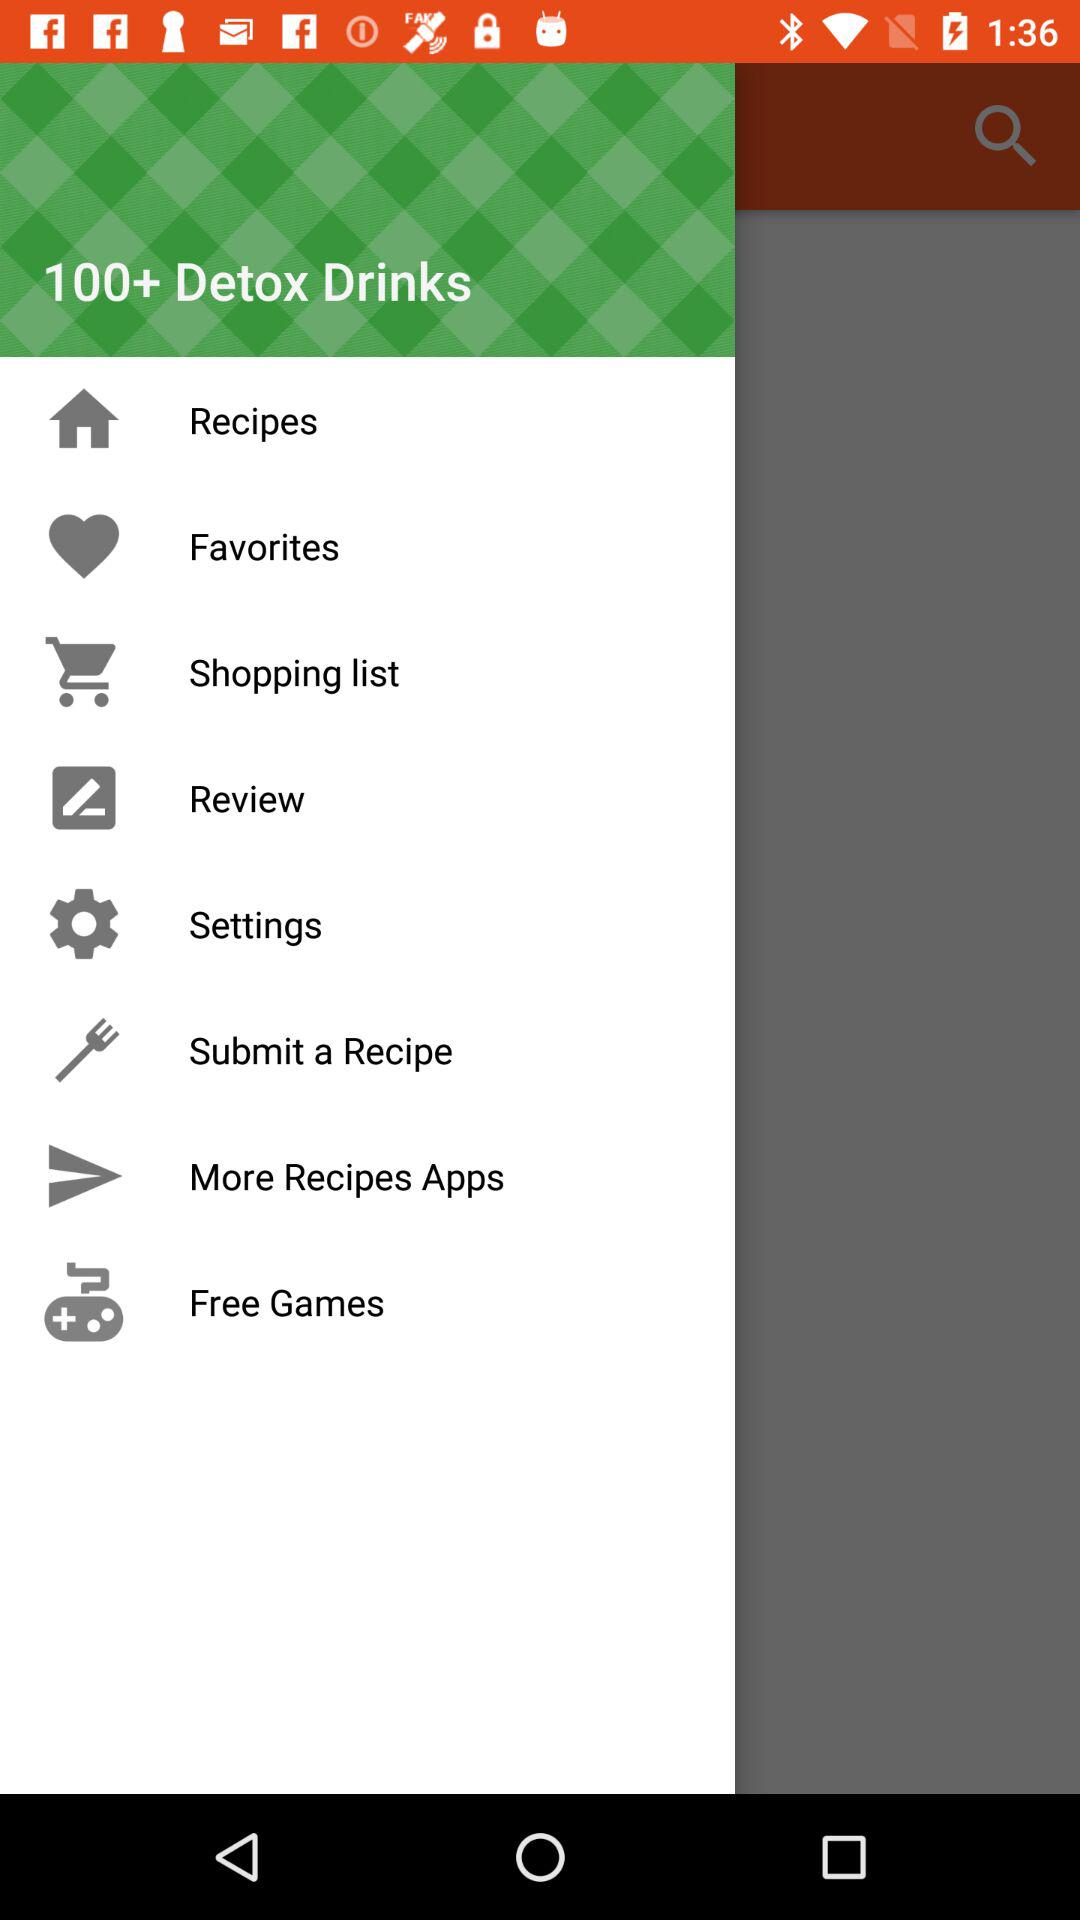What is the application name? The application name is "100+ Detox Drinks". 